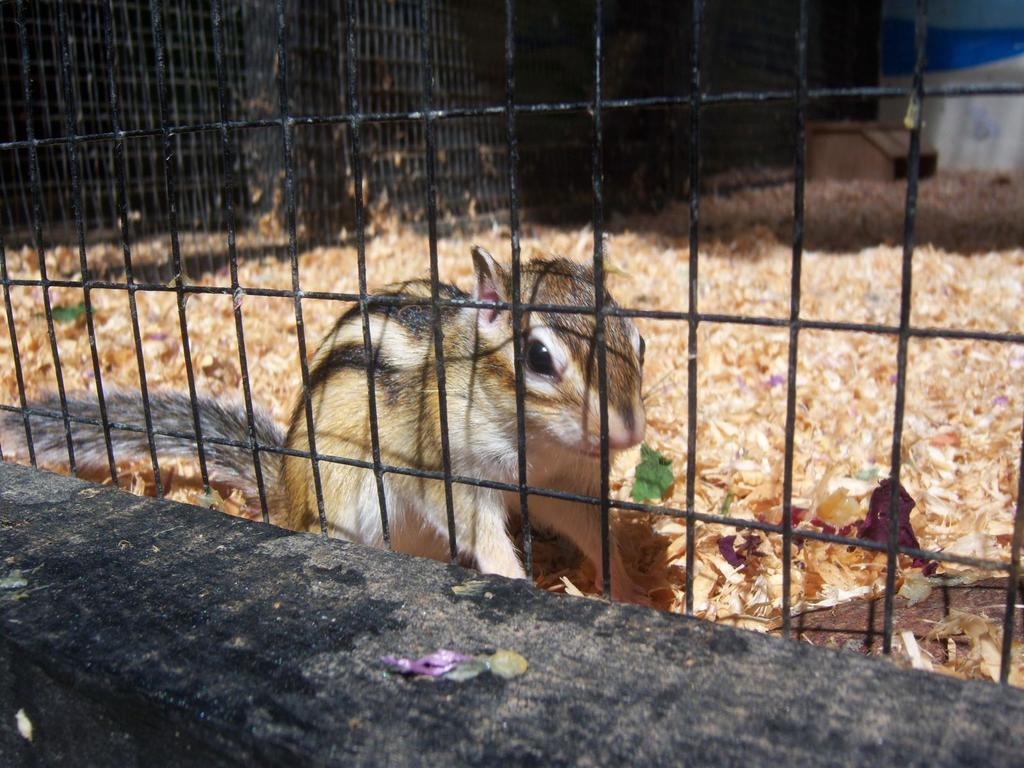What type of animal is in the image? There is a squirrel in the image. Where is the squirrel located? The squirrel is inside a cage. What can be seen at the bottom side of the image? There is a wooden log at the bottom side of the image. What is the relation between the squirrel and the father in the image? There is no father present in the image, and the squirrel's relation to any person cannot be determined. 